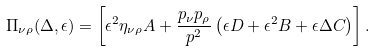<formula> <loc_0><loc_0><loc_500><loc_500>\Pi _ { \nu \rho } ( \Delta , \epsilon ) = \left [ \epsilon ^ { 2 } \eta _ { \nu \rho } A + \frac { p _ { \nu } p _ { \rho } } { p ^ { 2 } } \left ( \epsilon D + \epsilon ^ { 2 } B + \epsilon \Delta C \right ) \right ] .</formula> 